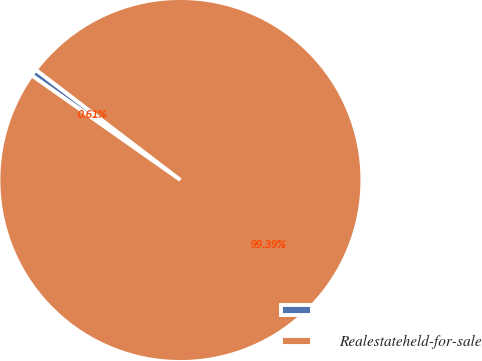Convert chart to OTSL. <chart><loc_0><loc_0><loc_500><loc_500><pie_chart><ecel><fcel>Realestateheld-for-sale<nl><fcel>0.61%<fcel>99.39%<nl></chart> 